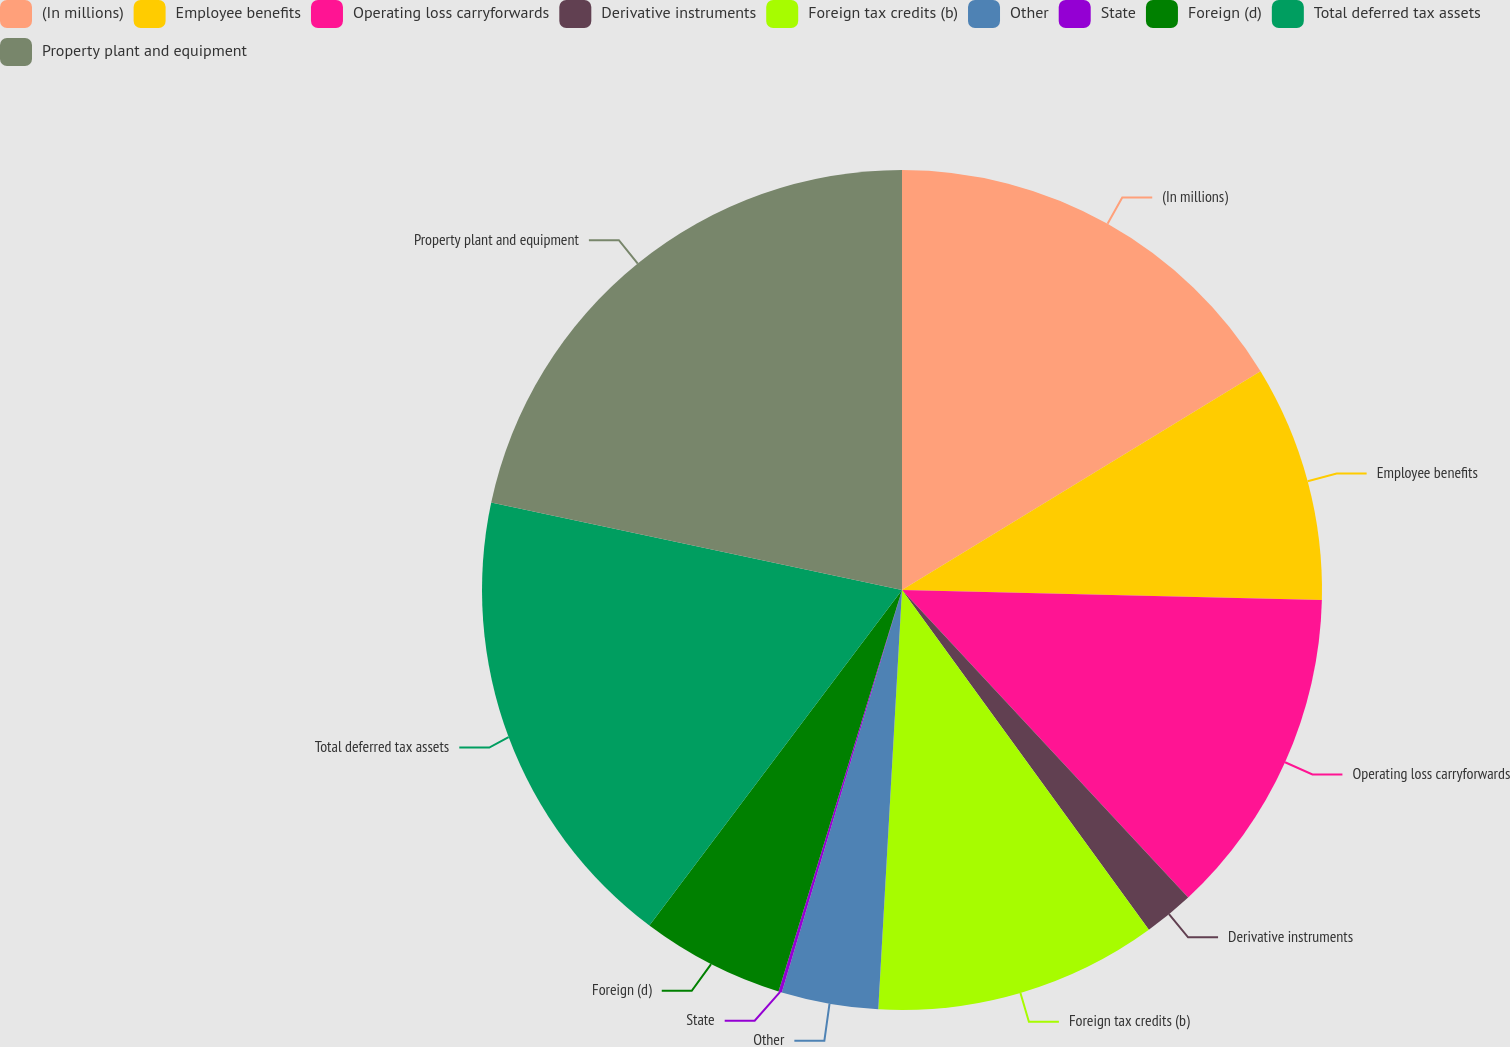<chart> <loc_0><loc_0><loc_500><loc_500><pie_chart><fcel>(In millions)<fcel>Employee benefits<fcel>Operating loss carryforwards<fcel>Derivative instruments<fcel>Foreign tax credits (b)<fcel>Other<fcel>State<fcel>Foreign (d)<fcel>Total deferred tax assets<fcel>Property plant and equipment<nl><fcel>16.28%<fcel>9.1%<fcel>12.69%<fcel>1.93%<fcel>10.9%<fcel>3.72%<fcel>0.13%<fcel>5.52%<fcel>18.07%<fcel>21.66%<nl></chart> 